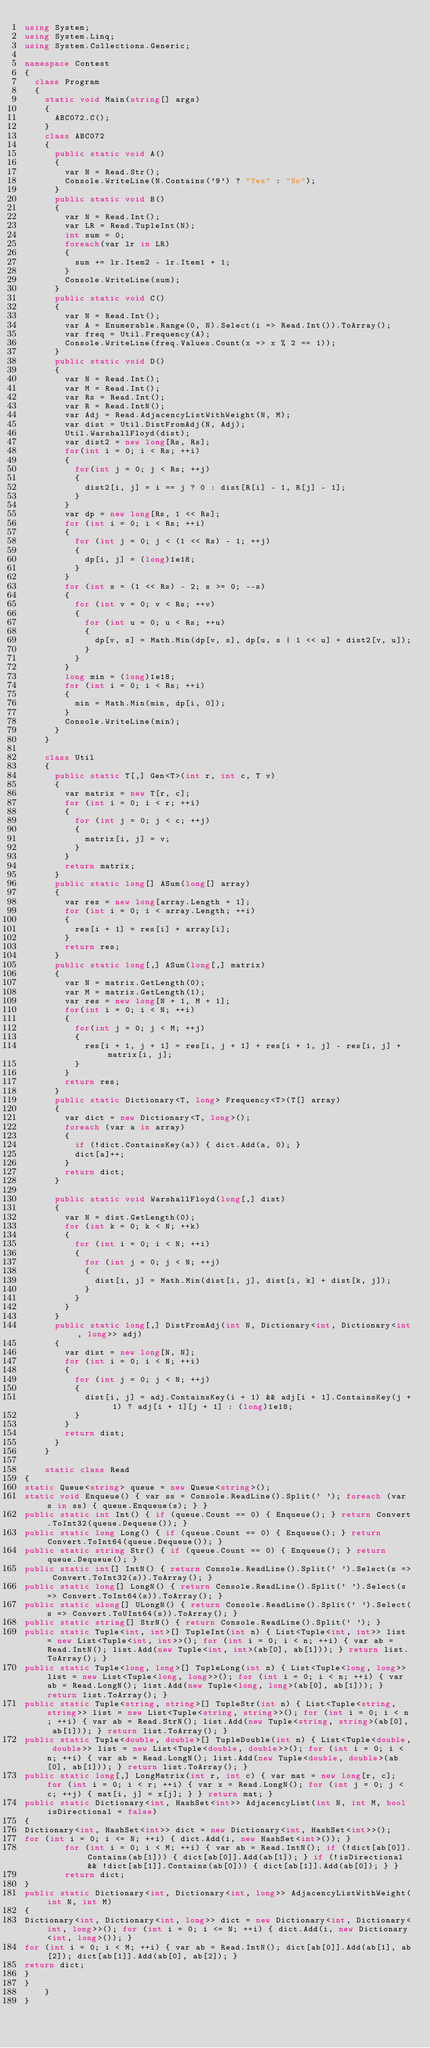Convert code to text. <code><loc_0><loc_0><loc_500><loc_500><_C#_>using System;
using System.Linq;
using System.Collections.Generic;

namespace Contest
{
  class Program
  {
    static void Main(string[] args)
    {
      ABC072.C();
    }
    class ABC072
    {
      public static void A()
      {
        var N = Read.Str();
        Console.WriteLine(N.Contains('9') ? "Yes" : "No");
      }
      public static void B()
      {
        var N = Read.Int();
        var LR = Read.TupleInt(N);
        int sum = 0;
        foreach(var lr in LR)
        {
          sum += lr.Item2 - lr.Item1 + 1;
        }
        Console.WriteLine(sum);
      }
      public static void C()
      {
        var N = Read.Int();
        var A = Enumerable.Range(0, N).Select(i => Read.Int()).ToArray();
        var freq = Util.Frequency(A);
        Console.WriteLine(freq.Values.Count(x => x % 2 == 1));
      }
      public static void D()
      {
        var N = Read.Int();
        var M = Read.Int();
        var Rs = Read.Int();
        var R = Read.IntN();
        var Adj = Read.AdjacencyListWithWeight(N, M);
        var dist = Util.DistFromAdj(N, Adj);
        Util.WarshallFloyd(dist);
        var dist2 = new long[Rs, Rs];
        for(int i = 0; i < Rs; ++i)
        {
          for(int j = 0; j < Rs; ++j)
          {
            dist2[i, j] = i == j ? 0 : dist[R[i] - 1, R[j] - 1];
          }
        }
        var dp = new long[Rs, 1 << Rs];
        for (int i = 0; i < Rs; ++i)
        {
          for (int j = 0; j < (1 << Rs) - 1; ++j)
          {
            dp[i, j] = (long)1e18;
          }
        }
        for (int s = (1 << Rs) - 2; s >= 0; --s)
        {
          for (int v = 0; v < Rs; ++v)
          {
            for (int u = 0; u < Rs; ++u)
            {
              dp[v, s] = Math.Min(dp[v, s], dp[u, s | 1 << u] + dist2[v, u]);
            }
          }
        }
        long min = (long)1e18;
        for (int i = 0; i < Rs; ++i)
        {
          min = Math.Min(min, dp[i, 0]);
        }
        Console.WriteLine(min);
      }
    }

    class Util
    {
      public static T[,] Gen<T>(int r, int c, T v)
      {
        var matrix = new T[r, c];
        for (int i = 0; i < r; ++i)
        {
          for (int j = 0; j < c; ++j)
          {
            matrix[i, j] = v;
          }
        }
        return matrix;
      }
      public static long[] ASum(long[] array)
      {
        var res = new long[array.Length + 1];
        for (int i = 0; i < array.Length; ++i)
        {
          res[i + 1] = res[i] + array[i];
        }
        return res;
      }
      public static long[,] ASum(long[,] matrix)
      {
        var N = matrix.GetLength(0);
        var M = matrix.GetLength(1);
        var res = new long[N + 1, M + 1];
        for(int i = 0; i < N; ++i)
        {
          for(int j = 0; j < M; ++j)
          {
            res[i + 1, j + 1] = res[i, j + 1] + res[i + 1, j] - res[i, j] + matrix[i, j];
          }
        }
        return res;
      }
      public static Dictionary<T, long> Frequency<T>(T[] array)
      {
        var dict = new Dictionary<T, long>();
        foreach (var a in array)
        {
          if (!dict.ContainsKey(a)) { dict.Add(a, 0); }
          dict[a]++;
        }
        return dict;
      }

      public static void WarshallFloyd(long[,] dist)
      {
        var N = dist.GetLength(0);
        for (int k = 0; k < N; ++k)
        {
          for (int i = 0; i < N; ++i)
          {
            for (int j = 0; j < N; ++j)
            {
              dist[i, j] = Math.Min(dist[i, j], dist[i, k] + dist[k, j]);
            }
          }
        }
      }
      public static long[,] DistFromAdj(int N, Dictionary<int, Dictionary<int, long>> adj)
      {
        var dist = new long[N, N];
        for (int i = 0; i < N; ++i)
        {
          for (int j = 0; j < N; ++j)
          {
            dist[i, j] = adj.ContainsKey(i + 1) && adj[i + 1].ContainsKey(j + 1) ? adj[i + 1][j + 1] : (long)1e18;
          }
        }
        return dist;
      }
    }

    static class Read
{
static Queue<string> queue = new Queue<string>();
static void Enqueue() { var ss = Console.ReadLine().Split(' '); foreach (var s in ss) { queue.Enqueue(s); } }
public static int Int() { if (queue.Count == 0) { Enqueue(); } return Convert.ToInt32(queue.Dequeue()); }
public static long Long() { if (queue.Count == 0) { Enqueue(); } return Convert.ToInt64(queue.Dequeue()); }
public static string Str() { if (queue.Count == 0) { Enqueue(); } return queue.Dequeue(); }
public static int[] IntN() { return Console.ReadLine().Split(' ').Select(s => Convert.ToInt32(s)).ToArray(); }
public static long[] LongN() { return Console.ReadLine().Split(' ').Select(s => Convert.ToInt64(s)).ToArray(); }
public static ulong[] ULongN() { return Console.ReadLine().Split(' ').Select(s => Convert.ToUInt64(s)).ToArray(); }
public static string[] StrN() { return Console.ReadLine().Split(' '); }
public static Tuple<int, int>[] TupleInt(int n) { List<Tuple<int, int>> list = new List<Tuple<int, int>>(); for (int i = 0; i < n; ++i) { var ab = Read.IntN(); list.Add(new Tuple<int, int>(ab[0], ab[1])); } return list.ToArray(); }
public static Tuple<long, long>[] TupleLong(int n) { List<Tuple<long, long>> list = new List<Tuple<long, long>>(); for (int i = 0; i < n; ++i) { var ab = Read.LongN(); list.Add(new Tuple<long, long>(ab[0], ab[1])); } return list.ToArray(); }
public static Tuple<string, string>[] TupleStr(int n) { List<Tuple<string, string>> list = new List<Tuple<string, string>>(); for (int i = 0; i < n; ++i) { var ab = Read.StrN(); list.Add(new Tuple<string, string>(ab[0], ab[1])); } return list.ToArray(); }
public static Tuple<double, double>[] TupleDouble(int n) { List<Tuple<double, double>> list = new List<Tuple<double, double>>(); for (int i = 0; i < n; ++i) { var ab = Read.LongN(); list.Add(new Tuple<double, double>(ab[0], ab[1])); } return list.ToArray(); }
public static long[,] LongMatrix(int r, int c) { var mat = new long[r, c]; for (int i = 0; i < r; ++i) { var x = Read.LongN(); for (int j = 0; j < c; ++j) { mat[i, j] = x[j]; } } return mat; }
public static Dictionary<int, HashSet<int>> AdjacencyList(int N, int M, bool isDirectional = false)
{
Dictionary<int, HashSet<int>> dict = new Dictionary<int, HashSet<int>>();
for (int i = 0; i <= N; ++i) { dict.Add(i, new HashSet<int>()); }
        for (int i = 0; i < M; ++i) { var ab = Read.IntN(); if (!dict[ab[0]].Contains(ab[1])) { dict[ab[0]].Add(ab[1]); } if (!isDirectional && !dict[ab[1]].Contains(ab[0])) { dict[ab[1]].Add(ab[0]); } }
        return dict;
}
public static Dictionary<int, Dictionary<int, long>> AdjacencyListWithWeight(int N, int M)
{
Dictionary<int, Dictionary<int, long>> dict = new Dictionary<int, Dictionary<int, long>>(); for (int i = 0; i <= N; ++i) { dict.Add(i, new Dictionary<int, long>()); }
for (int i = 0; i < M; ++i) { var ab = Read.IntN(); dict[ab[0]].Add(ab[1], ab[2]); dict[ab[1]].Add(ab[0], ab[2]); }
return dict;
}
}
    }
}
</code> 